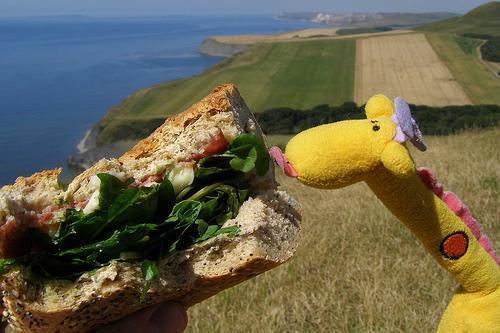How many sandwiches are there?
Give a very brief answer. 1. 